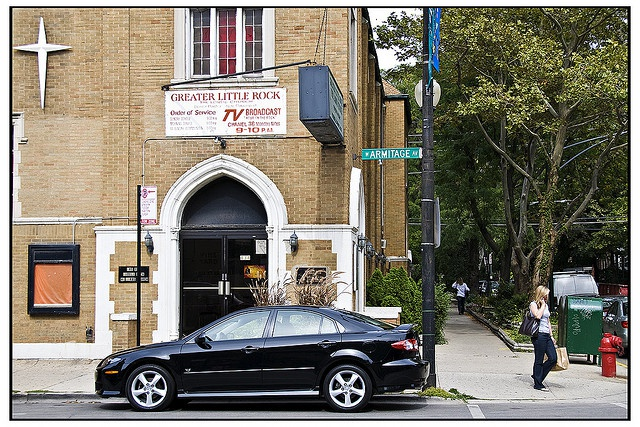Describe the objects in this image and their specific colors. I can see car in white, black, lightgray, and gray tones, people in white, black, lightgray, navy, and gray tones, car in white, lightgray, black, and darkgray tones, truck in white, lightgray, darkgray, and black tones, and car in white, black, purple, and darkgray tones in this image. 